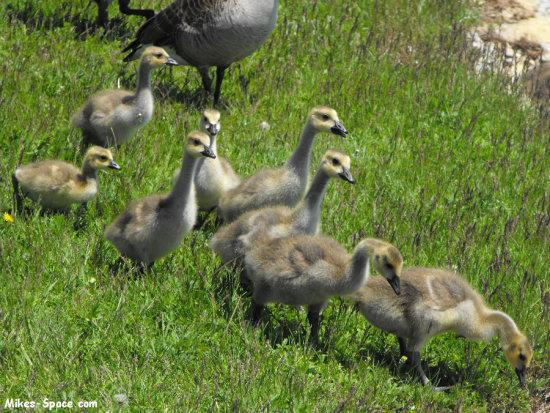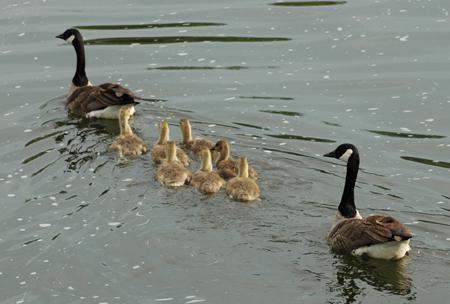The first image is the image on the left, the second image is the image on the right. Given the left and right images, does the statement "The ducks in the left image are all facing towards the right." hold true? Answer yes or no. Yes. The first image is the image on the left, the second image is the image on the right. Considering the images on both sides, is "There are two adult geese leading no more than seven ducking." valid? Answer yes or no. Yes. 